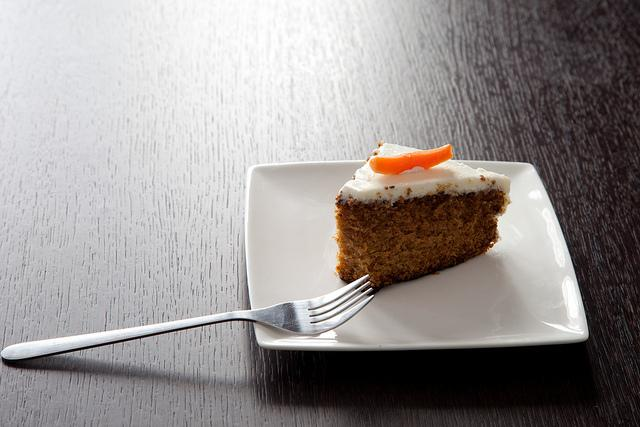What kind of cake has been served? carrot 